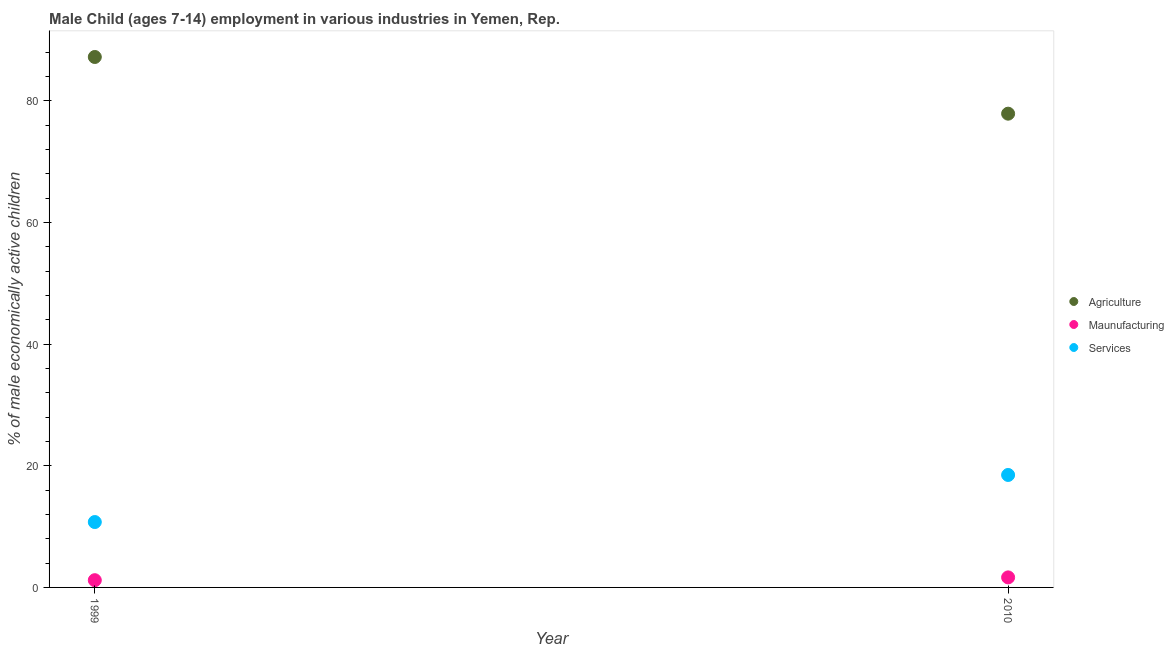How many different coloured dotlines are there?
Provide a succinct answer. 3. Is the number of dotlines equal to the number of legend labels?
Provide a short and direct response. Yes. What is the percentage of economically active children in services in 2010?
Keep it short and to the point. 18.49. Across all years, what is the maximum percentage of economically active children in manufacturing?
Offer a terse response. 1.65. Across all years, what is the minimum percentage of economically active children in agriculture?
Your answer should be very brief. 77.89. In which year was the percentage of economically active children in agriculture minimum?
Provide a succinct answer. 2010. What is the total percentage of economically active children in services in the graph?
Your answer should be very brief. 29.24. What is the difference between the percentage of economically active children in services in 1999 and that in 2010?
Your response must be concise. -7.74. What is the difference between the percentage of economically active children in agriculture in 2010 and the percentage of economically active children in services in 1999?
Give a very brief answer. 67.14. What is the average percentage of economically active children in manufacturing per year?
Keep it short and to the point. 1.42. In the year 2010, what is the difference between the percentage of economically active children in services and percentage of economically active children in manufacturing?
Your answer should be very brief. 16.84. What is the ratio of the percentage of economically active children in manufacturing in 1999 to that in 2010?
Provide a short and direct response. 0.72. Is the percentage of economically active children in agriculture in 1999 less than that in 2010?
Offer a very short reply. No. Is the percentage of economically active children in services strictly greater than the percentage of economically active children in agriculture over the years?
Your answer should be very brief. No. What is the difference between two consecutive major ticks on the Y-axis?
Provide a short and direct response. 20. Are the values on the major ticks of Y-axis written in scientific E-notation?
Offer a terse response. No. Where does the legend appear in the graph?
Your answer should be very brief. Center right. How are the legend labels stacked?
Offer a terse response. Vertical. What is the title of the graph?
Offer a terse response. Male Child (ages 7-14) employment in various industries in Yemen, Rep. Does "Social Insurance" appear as one of the legend labels in the graph?
Offer a very short reply. No. What is the label or title of the X-axis?
Provide a short and direct response. Year. What is the label or title of the Y-axis?
Give a very brief answer. % of male economically active children. What is the % of male economically active children in Agriculture in 1999?
Keep it short and to the point. 87.21. What is the % of male economically active children of Maunufacturing in 1999?
Give a very brief answer. 1.19. What is the % of male economically active children of Services in 1999?
Give a very brief answer. 10.75. What is the % of male economically active children of Agriculture in 2010?
Offer a terse response. 77.89. What is the % of male economically active children of Maunufacturing in 2010?
Ensure brevity in your answer.  1.65. What is the % of male economically active children of Services in 2010?
Your answer should be compact. 18.49. Across all years, what is the maximum % of male economically active children of Agriculture?
Your response must be concise. 87.21. Across all years, what is the maximum % of male economically active children in Maunufacturing?
Offer a very short reply. 1.65. Across all years, what is the maximum % of male economically active children of Services?
Your answer should be very brief. 18.49. Across all years, what is the minimum % of male economically active children of Agriculture?
Give a very brief answer. 77.89. Across all years, what is the minimum % of male economically active children in Maunufacturing?
Offer a very short reply. 1.19. Across all years, what is the minimum % of male economically active children of Services?
Your answer should be very brief. 10.75. What is the total % of male economically active children in Agriculture in the graph?
Your response must be concise. 165.1. What is the total % of male economically active children of Maunufacturing in the graph?
Keep it short and to the point. 2.84. What is the total % of male economically active children of Services in the graph?
Your answer should be very brief. 29.24. What is the difference between the % of male economically active children of Agriculture in 1999 and that in 2010?
Your answer should be compact. 9.32. What is the difference between the % of male economically active children of Maunufacturing in 1999 and that in 2010?
Your answer should be compact. -0.46. What is the difference between the % of male economically active children in Services in 1999 and that in 2010?
Ensure brevity in your answer.  -7.74. What is the difference between the % of male economically active children in Agriculture in 1999 and the % of male economically active children in Maunufacturing in 2010?
Offer a terse response. 85.56. What is the difference between the % of male economically active children of Agriculture in 1999 and the % of male economically active children of Services in 2010?
Ensure brevity in your answer.  68.72. What is the difference between the % of male economically active children in Maunufacturing in 1999 and the % of male economically active children in Services in 2010?
Offer a very short reply. -17.3. What is the average % of male economically active children of Agriculture per year?
Your response must be concise. 82.55. What is the average % of male economically active children of Maunufacturing per year?
Provide a succinct answer. 1.42. What is the average % of male economically active children in Services per year?
Your answer should be very brief. 14.62. In the year 1999, what is the difference between the % of male economically active children in Agriculture and % of male economically active children in Maunufacturing?
Make the answer very short. 86.02. In the year 1999, what is the difference between the % of male economically active children in Agriculture and % of male economically active children in Services?
Give a very brief answer. 76.46. In the year 1999, what is the difference between the % of male economically active children in Maunufacturing and % of male economically active children in Services?
Offer a very short reply. -9.56. In the year 2010, what is the difference between the % of male economically active children of Agriculture and % of male economically active children of Maunufacturing?
Your response must be concise. 76.24. In the year 2010, what is the difference between the % of male economically active children in Agriculture and % of male economically active children in Services?
Offer a terse response. 59.4. In the year 2010, what is the difference between the % of male economically active children of Maunufacturing and % of male economically active children of Services?
Your answer should be very brief. -16.84. What is the ratio of the % of male economically active children in Agriculture in 1999 to that in 2010?
Offer a very short reply. 1.12. What is the ratio of the % of male economically active children of Maunufacturing in 1999 to that in 2010?
Offer a terse response. 0.72. What is the ratio of the % of male economically active children of Services in 1999 to that in 2010?
Your answer should be compact. 0.58. What is the difference between the highest and the second highest % of male economically active children in Agriculture?
Offer a terse response. 9.32. What is the difference between the highest and the second highest % of male economically active children in Maunufacturing?
Offer a terse response. 0.46. What is the difference between the highest and the second highest % of male economically active children in Services?
Give a very brief answer. 7.74. What is the difference between the highest and the lowest % of male economically active children of Agriculture?
Your answer should be compact. 9.32. What is the difference between the highest and the lowest % of male economically active children of Maunufacturing?
Offer a terse response. 0.46. What is the difference between the highest and the lowest % of male economically active children in Services?
Provide a succinct answer. 7.74. 